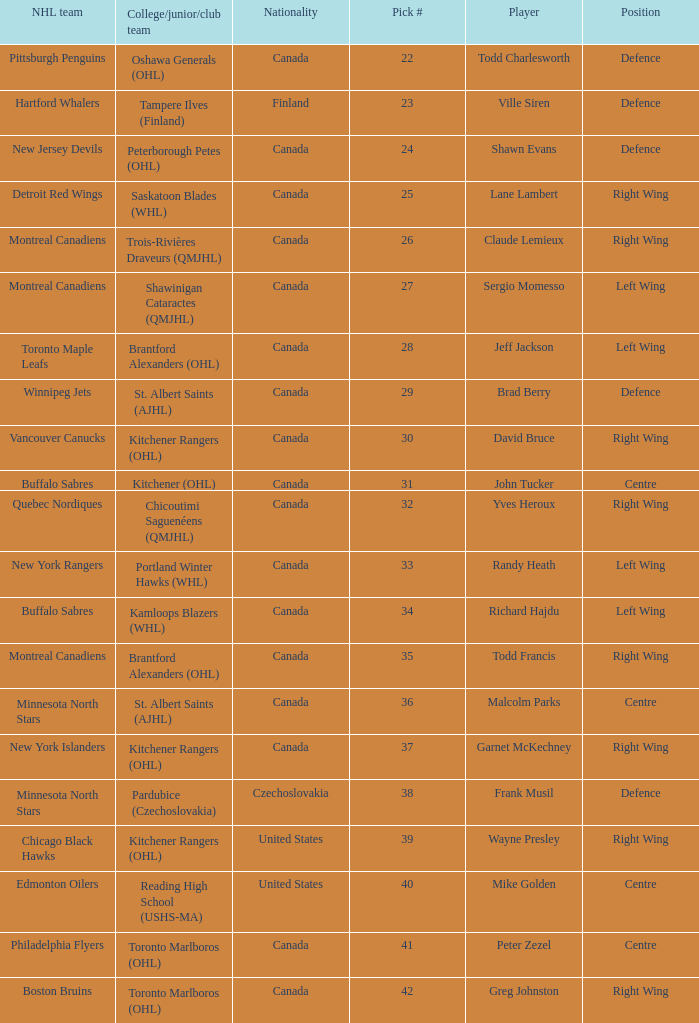What is the nhl team when the college, junior, club team is toronto marlboros (ohl) and the position is centre? Philadelphia Flyers. 